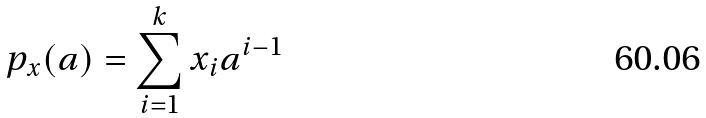Convert formula to latex. <formula><loc_0><loc_0><loc_500><loc_500>p _ { x } ( a ) = \sum _ { i = 1 } ^ { k } x _ { i } a ^ { i - 1 }</formula> 